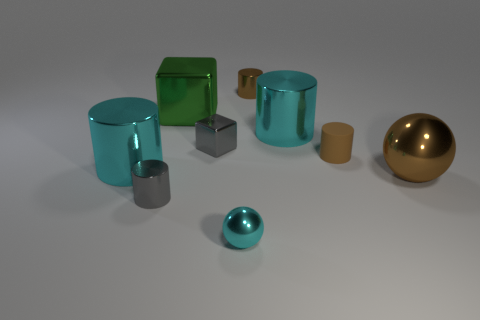Is the number of small cyan spheres that are on the right side of the tiny cyan object the same as the number of cyan metal cylinders that are behind the green thing? Upon examining the image, I can confirm that the number of small cyan spheres situated to the right of the tiny cyan object is indeed equivalent to the number of cyan metal cylinders located posterior to the green opaque cube. Both sets comprise two items each, creating a state of numerical balance within this particular arrangement. 